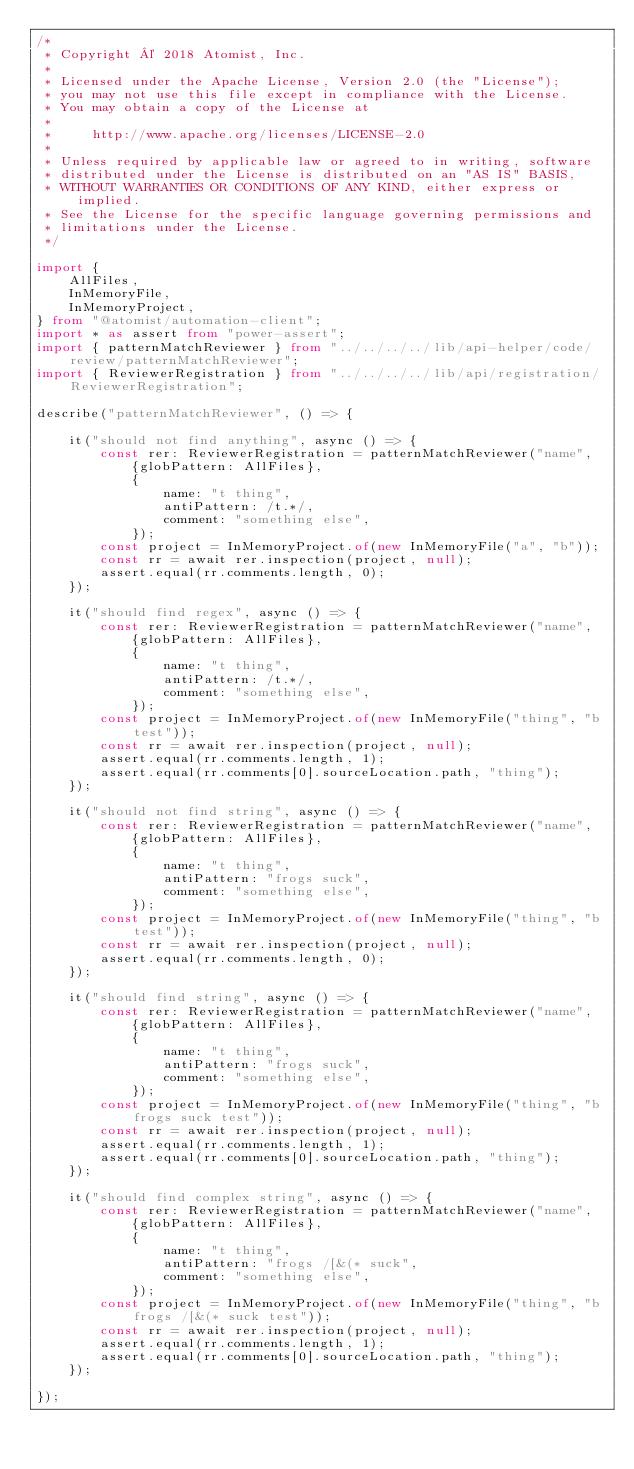<code> <loc_0><loc_0><loc_500><loc_500><_TypeScript_>/*
 * Copyright © 2018 Atomist, Inc.
 *
 * Licensed under the Apache License, Version 2.0 (the "License");
 * you may not use this file except in compliance with the License.
 * You may obtain a copy of the License at
 *
 *     http://www.apache.org/licenses/LICENSE-2.0
 *
 * Unless required by applicable law or agreed to in writing, software
 * distributed under the License is distributed on an "AS IS" BASIS,
 * WITHOUT WARRANTIES OR CONDITIONS OF ANY KIND, either express or implied.
 * See the License for the specific language governing permissions and
 * limitations under the License.
 */

import {
    AllFiles,
    InMemoryFile,
    InMemoryProject,
} from "@atomist/automation-client";
import * as assert from "power-assert";
import { patternMatchReviewer } from "../../../../lib/api-helper/code/review/patternMatchReviewer";
import { ReviewerRegistration } from "../../../../lib/api/registration/ReviewerRegistration";

describe("patternMatchReviewer", () => {

    it("should not find anything", async () => {
        const rer: ReviewerRegistration = patternMatchReviewer("name",
            {globPattern: AllFiles},
            {
                name: "t thing",
                antiPattern: /t.*/,
                comment: "something else",
            });
        const project = InMemoryProject.of(new InMemoryFile("a", "b"));
        const rr = await rer.inspection(project, null);
        assert.equal(rr.comments.length, 0);
    });

    it("should find regex", async () => {
        const rer: ReviewerRegistration = patternMatchReviewer("name",
            {globPattern: AllFiles},
            {
                name: "t thing",
                antiPattern: /t.*/,
                comment: "something else",
            });
        const project = InMemoryProject.of(new InMemoryFile("thing", "b test"));
        const rr = await rer.inspection(project, null);
        assert.equal(rr.comments.length, 1);
        assert.equal(rr.comments[0].sourceLocation.path, "thing");
    });

    it("should not find string", async () => {
        const rer: ReviewerRegistration = patternMatchReviewer("name",
            {globPattern: AllFiles},
            {
                name: "t thing",
                antiPattern: "frogs suck",
                comment: "something else",
            });
        const project = InMemoryProject.of(new InMemoryFile("thing", "b test"));
        const rr = await rer.inspection(project, null);
        assert.equal(rr.comments.length, 0);
    });

    it("should find string", async () => {
        const rer: ReviewerRegistration = patternMatchReviewer("name",
            {globPattern: AllFiles},
            {
                name: "t thing",
                antiPattern: "frogs suck",
                comment: "something else",
            });
        const project = InMemoryProject.of(new InMemoryFile("thing", "b frogs suck test"));
        const rr = await rer.inspection(project, null);
        assert.equal(rr.comments.length, 1);
        assert.equal(rr.comments[0].sourceLocation.path, "thing");
    });

    it("should find complex string", async () => {
        const rer: ReviewerRegistration = patternMatchReviewer("name",
            {globPattern: AllFiles},
            {
                name: "t thing",
                antiPattern: "frogs /[&(* suck",
                comment: "something else",
            });
        const project = InMemoryProject.of(new InMemoryFile("thing", "b frogs /[&(* suck test"));
        const rr = await rer.inspection(project, null);
        assert.equal(rr.comments.length, 1);
        assert.equal(rr.comments[0].sourceLocation.path, "thing");
    });

});
</code> 